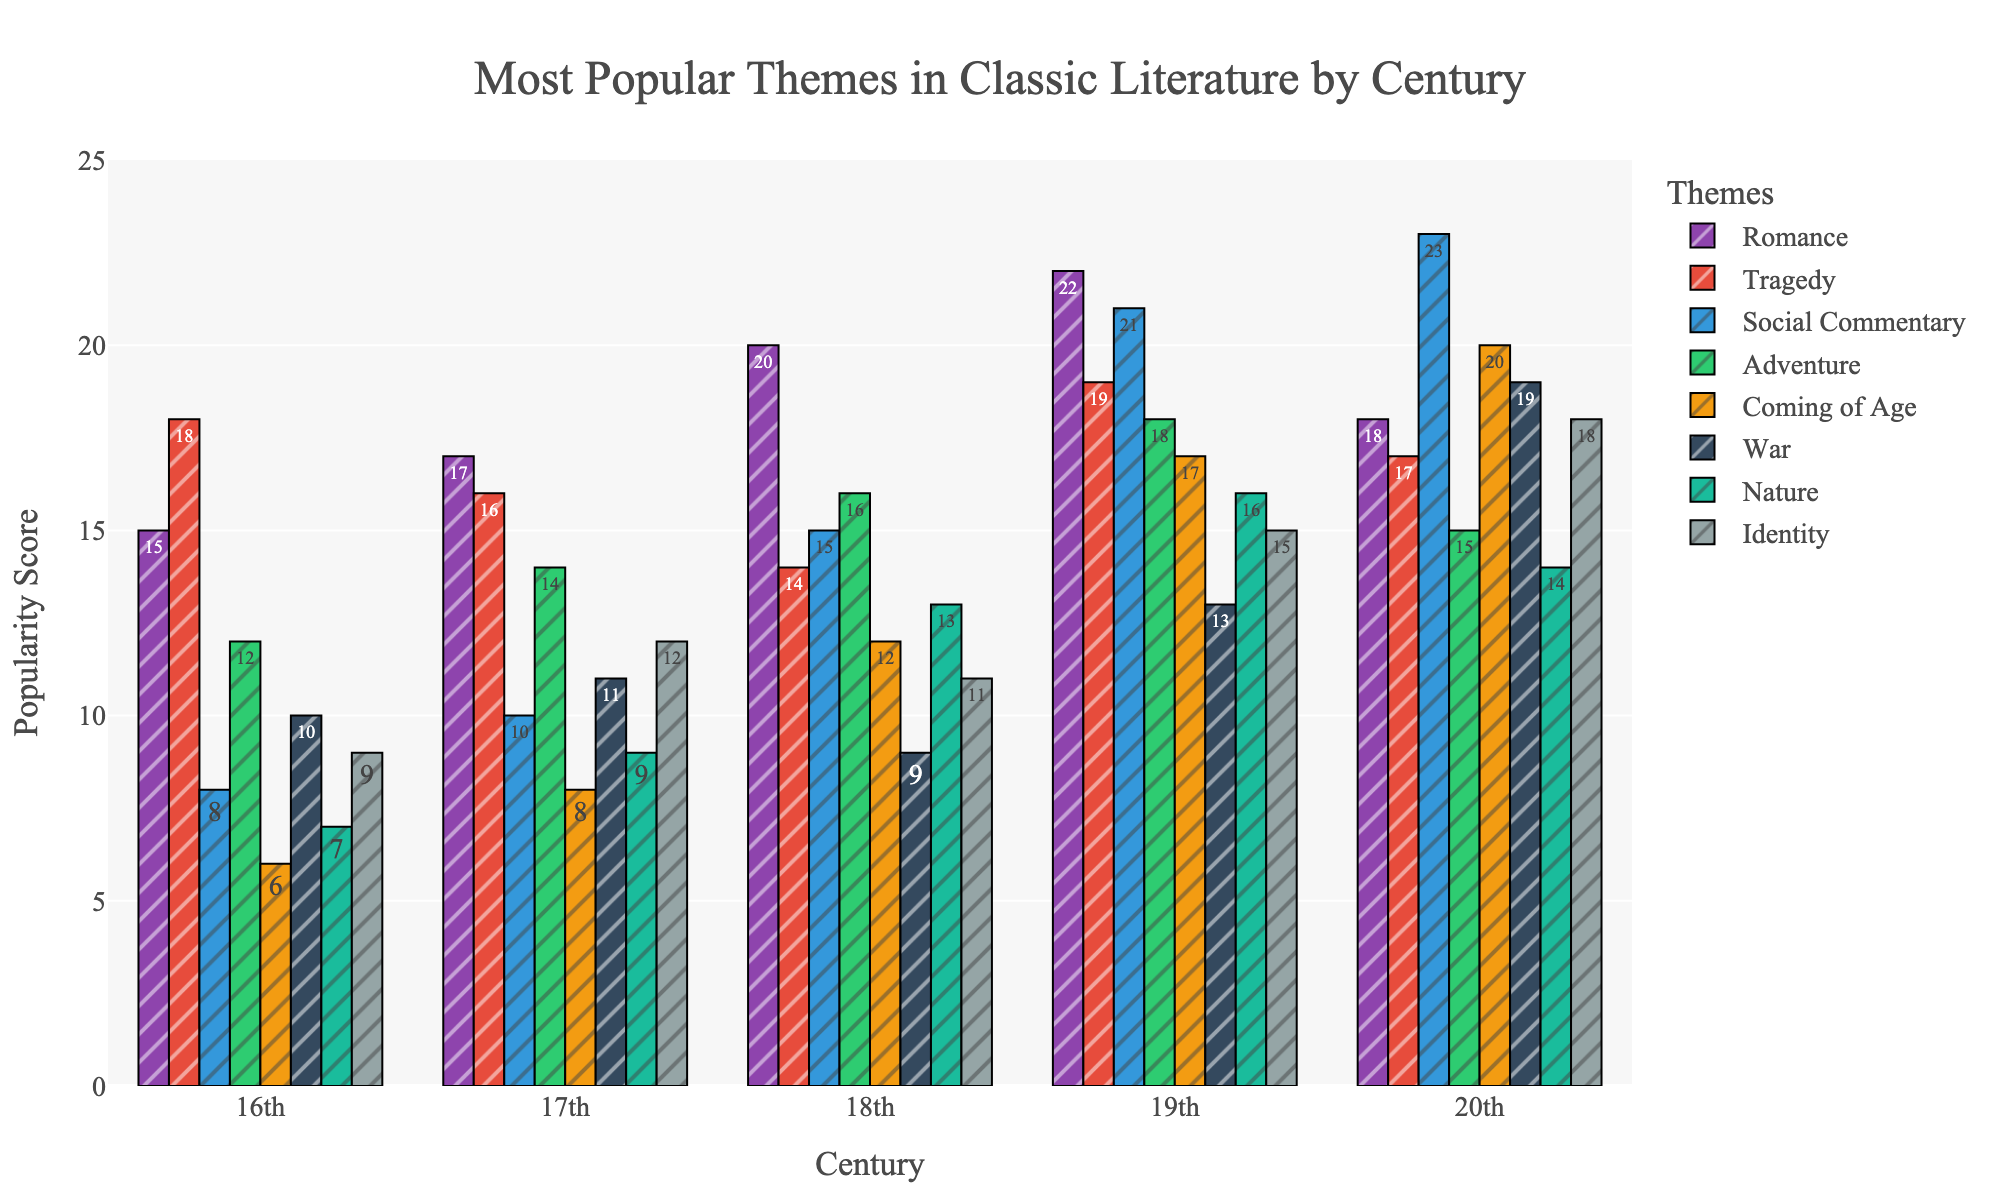What's the most popular theme in the 19th century? Observe the highest bar in the 19th-century group. The highest bar belongs to "Social Commentary" with a value of 21.
Answer: Social Commentary How does the popularity of the theme "War" change from the 16th to the 20th century? Look at the height of the bars representing "War" across the centuries. In the 16th century, the value is 10; in the 17th, it is 11; in the 18th, it is 9; in the 19th, it is 13; and in the 20th, it is 19.
Answer: It increases overall Which century has the lowest popularity score for "Coming of Age"? Identify the shortest bar for "Coming of Age" across all centuries. The 16th century has the lowest score with a value of 6.
Answer: 16th century What's the average popularity score of "Romance" across all centuries? Sum the values for "Romance" (15+17+20+22+18) = 92 and divide by the number of centuries (5). So, the average is 92/5 = 18.4.
Answer: 18.4 Which theme saw the most significant increase in popularity from the 18th to the 19th century? Compare the differences between the values of each theme from the 18th to the 19th century. "Coming of Age" saw the most significant increase (from 12 to 17), an increase of 5 units.
Answer: Coming of Age Between "Tragedy" and "Adventure," which theme was more popular in the 17th century? Compare the bars for "Tragedy" and "Adventure" in the 17th century. "Tragedy" has a value of 16, and "Adventure" has a value of 14, so "Tragedy" is more popular.
Answer: Tragedy How much more popular was the theme "Nature" compared to "Romance" in the 18th century? Subtract the "Romance" value from the "Nature" value in the 18th century: 13 - 20 = -7. "Romance" was more popular by 7 units.
Answer: 7 What’s the total popularity score for all themes in the 20th century? Sum all the values for each theme in the 20th century: 18+17+23+15+20+19+14+18 = 144.
Answer: 144 Which theme has the most consistent popularity across centuries? Look for the theme with the least variation in bar heights across all centuries. "Nature" shows values close to each other (7, 9, 13, 16, 14).
Answer: Nature 